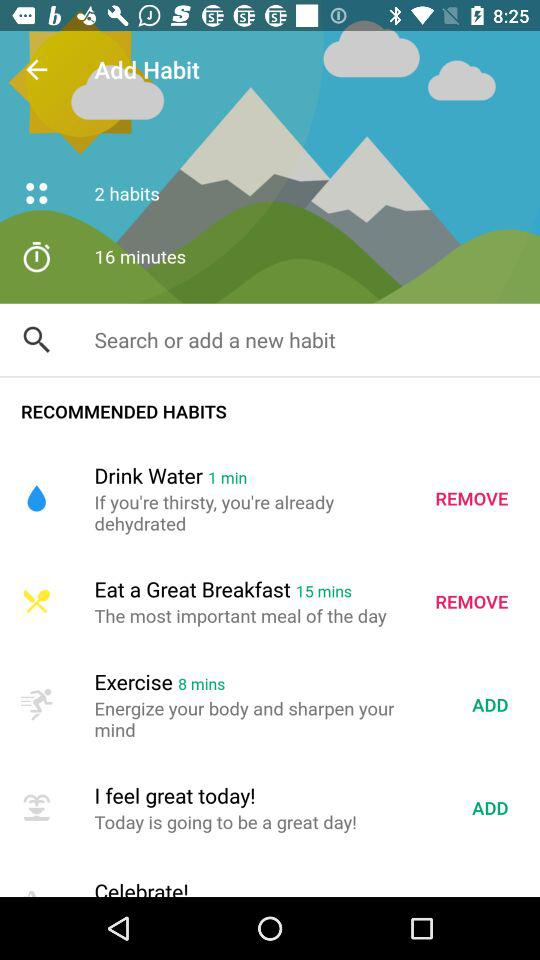What is the total habit time shown on the screen? The total habit time is 16 minutes. 